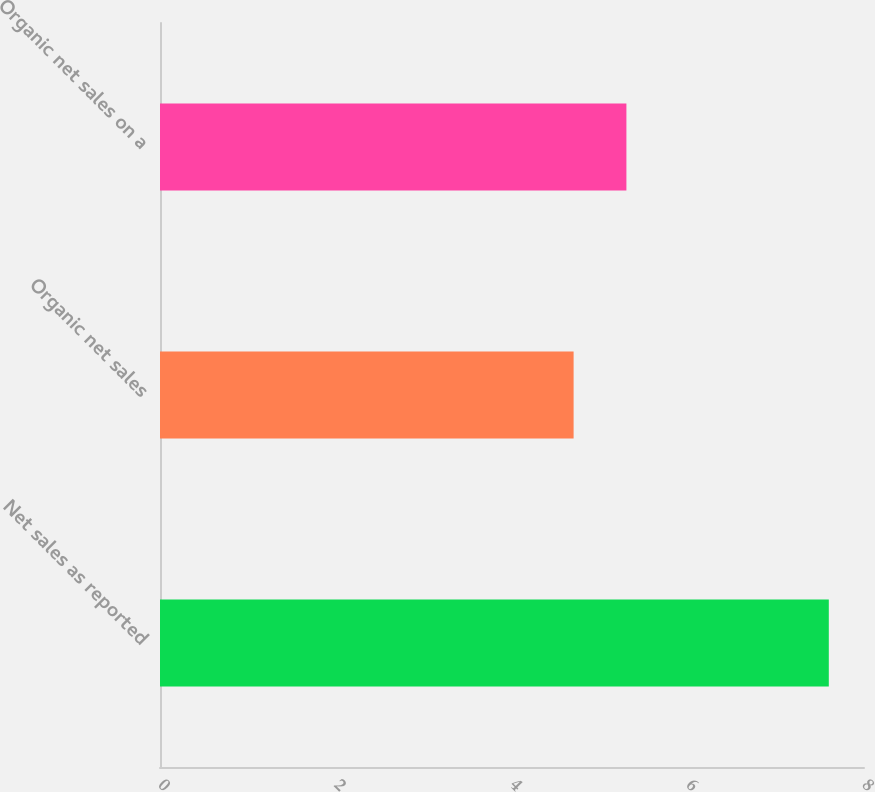Convert chart to OTSL. <chart><loc_0><loc_0><loc_500><loc_500><bar_chart><fcel>Net sales as reported<fcel>Organic net sales<fcel>Organic net sales on a<nl><fcel>7.6<fcel>4.7<fcel>5.3<nl></chart> 